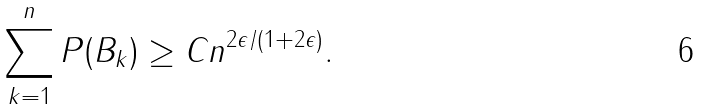Convert formula to latex. <formula><loc_0><loc_0><loc_500><loc_500>\sum _ { k = 1 } ^ { n } P ( B _ { k } ) \geq C n ^ { 2 \epsilon / ( 1 + 2 \epsilon ) } .</formula> 